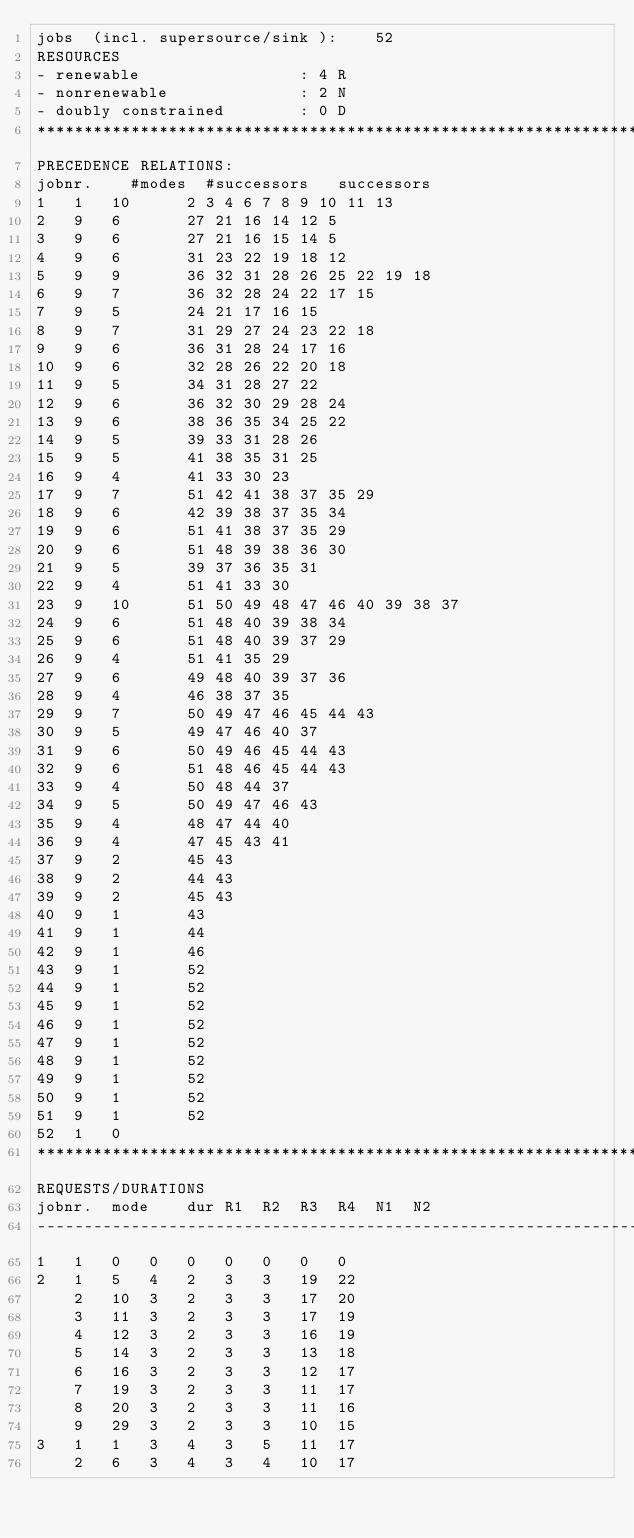<code> <loc_0><loc_0><loc_500><loc_500><_ObjectiveC_>jobs  (incl. supersource/sink ):	52
RESOURCES
- renewable                 : 4 R
- nonrenewable              : 2 N
- doubly constrained        : 0 D
************************************************************************
PRECEDENCE RELATIONS:
jobnr.    #modes  #successors   successors
1	1	10		2 3 4 6 7 8 9 10 11 13 
2	9	6		27 21 16 14 12 5 
3	9	6		27 21 16 15 14 5 
4	9	6		31 23 22 19 18 12 
5	9	9		36 32 31 28 26 25 22 19 18 
6	9	7		36 32 28 24 22 17 15 
7	9	5		24 21 17 16 15 
8	9	7		31 29 27 24 23 22 18 
9	9	6		36 31 28 24 17 16 
10	9	6		32 28 26 22 20 18 
11	9	5		34 31 28 27 22 
12	9	6		36 32 30 29 28 24 
13	9	6		38 36 35 34 25 22 
14	9	5		39 33 31 28 26 
15	9	5		41 38 35 31 25 
16	9	4		41 33 30 23 
17	9	7		51 42 41 38 37 35 29 
18	9	6		42 39 38 37 35 34 
19	9	6		51 41 38 37 35 29 
20	9	6		51 48 39 38 36 30 
21	9	5		39 37 36 35 31 
22	9	4		51 41 33 30 
23	9	10		51 50 49 48 47 46 40 39 38 37 
24	9	6		51 48 40 39 38 34 
25	9	6		51 48 40 39 37 29 
26	9	4		51 41 35 29 
27	9	6		49 48 40 39 37 36 
28	9	4		46 38 37 35 
29	9	7		50 49 47 46 45 44 43 
30	9	5		49 47 46 40 37 
31	9	6		50 49 46 45 44 43 
32	9	6		51 48 46 45 44 43 
33	9	4		50 48 44 37 
34	9	5		50 49 47 46 43 
35	9	4		48 47 44 40 
36	9	4		47 45 43 41 
37	9	2		45 43 
38	9	2		44 43 
39	9	2		45 43 
40	9	1		43 
41	9	1		44 
42	9	1		46 
43	9	1		52 
44	9	1		52 
45	9	1		52 
46	9	1		52 
47	9	1		52 
48	9	1		52 
49	9	1		52 
50	9	1		52 
51	9	1		52 
52	1	0		
************************************************************************
REQUESTS/DURATIONS
jobnr.	mode	dur	R1	R2	R3	R4	N1	N2	
------------------------------------------------------------------------
1	1	0	0	0	0	0	0	0	
2	1	5	4	2	3	3	19	22	
	2	10	3	2	3	3	17	20	
	3	11	3	2	3	3	17	19	
	4	12	3	2	3	3	16	19	
	5	14	3	2	3	3	13	18	
	6	16	3	2	3	3	12	17	
	7	19	3	2	3	3	11	17	
	8	20	3	2	3	3	11	16	
	9	29	3	2	3	3	10	15	
3	1	1	3	4	3	5	11	17	
	2	6	3	4	3	4	10	17	</code> 